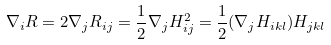Convert formula to latex. <formula><loc_0><loc_0><loc_500><loc_500>\nabla _ { i } R = 2 \nabla _ { j } R _ { i j } = \frac { 1 } { 2 } \nabla _ { j } H ^ { 2 } _ { i j } = \frac { 1 } { 2 } ( \nabla _ { j } H _ { i k l } ) H _ { j k l }</formula> 